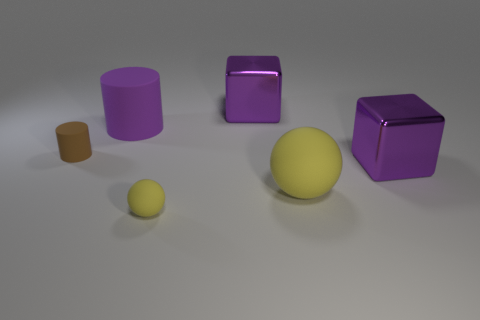Add 3 large purple cylinders. How many objects exist? 9 Subtract all purple metal cubes. Subtract all small matte balls. How many objects are left? 3 Add 3 tiny cylinders. How many tiny cylinders are left? 4 Add 5 tiny things. How many tiny things exist? 7 Subtract 0 blue cubes. How many objects are left? 6 